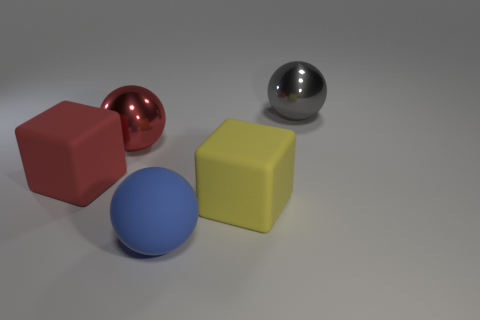Subtract all yellow blocks. Subtract all brown balls. How many blocks are left? 1 Add 4 tiny blue blocks. How many objects exist? 9 Subtract all balls. How many objects are left? 2 Add 2 big gray metallic things. How many big gray metallic things are left? 3 Add 5 big red metallic objects. How many big red metallic objects exist? 6 Subtract 0 brown spheres. How many objects are left? 5 Subtract all brown rubber cylinders. Subtract all large red matte things. How many objects are left? 4 